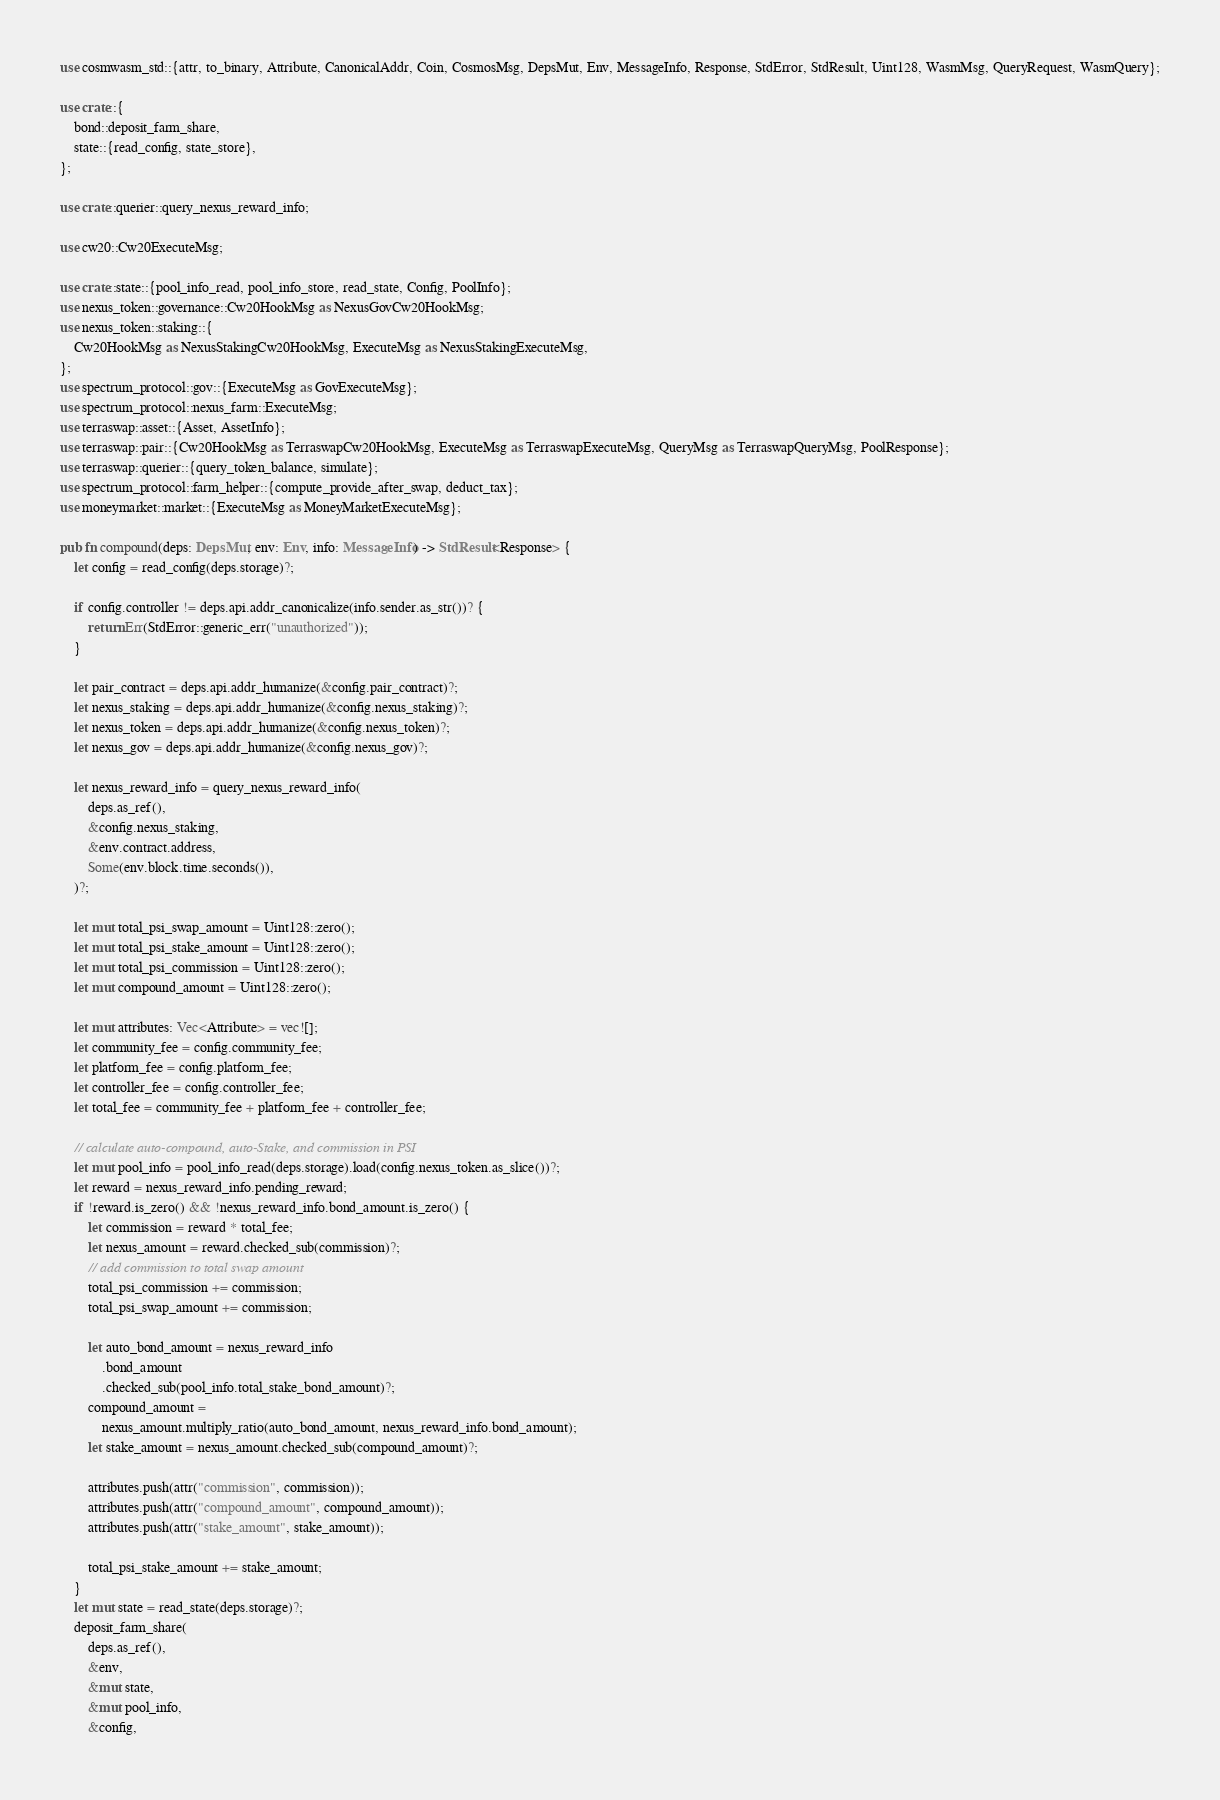Convert code to text. <code><loc_0><loc_0><loc_500><loc_500><_Rust_>use cosmwasm_std::{attr, to_binary, Attribute, CanonicalAddr, Coin, CosmosMsg, DepsMut, Env, MessageInfo, Response, StdError, StdResult, Uint128, WasmMsg, QueryRequest, WasmQuery};

use crate::{
    bond::deposit_farm_share,
    state::{read_config, state_store},
};

use crate::querier::query_nexus_reward_info;

use cw20::Cw20ExecuteMsg;

use crate::state::{pool_info_read, pool_info_store, read_state, Config, PoolInfo};
use nexus_token::governance::Cw20HookMsg as NexusGovCw20HookMsg;
use nexus_token::staking::{
    Cw20HookMsg as NexusStakingCw20HookMsg, ExecuteMsg as NexusStakingExecuteMsg,
};
use spectrum_protocol::gov::{ExecuteMsg as GovExecuteMsg};
use spectrum_protocol::nexus_farm::ExecuteMsg;
use terraswap::asset::{Asset, AssetInfo};
use terraswap::pair::{Cw20HookMsg as TerraswapCw20HookMsg, ExecuteMsg as TerraswapExecuteMsg, QueryMsg as TerraswapQueryMsg, PoolResponse};
use terraswap::querier::{query_token_balance, simulate};
use spectrum_protocol::farm_helper::{compute_provide_after_swap, deduct_tax};
use moneymarket::market::{ExecuteMsg as MoneyMarketExecuteMsg};

pub fn compound(deps: DepsMut, env: Env, info: MessageInfo) -> StdResult<Response> {
    let config = read_config(deps.storage)?;

    if config.controller != deps.api.addr_canonicalize(info.sender.as_str())? {
        return Err(StdError::generic_err("unauthorized"));
    }

    let pair_contract = deps.api.addr_humanize(&config.pair_contract)?;
    let nexus_staking = deps.api.addr_humanize(&config.nexus_staking)?;
    let nexus_token = deps.api.addr_humanize(&config.nexus_token)?;
    let nexus_gov = deps.api.addr_humanize(&config.nexus_gov)?;

    let nexus_reward_info = query_nexus_reward_info(
        deps.as_ref(),
        &config.nexus_staking,
        &env.contract.address,
        Some(env.block.time.seconds()),
    )?;

    let mut total_psi_swap_amount = Uint128::zero();
    let mut total_psi_stake_amount = Uint128::zero();
    let mut total_psi_commission = Uint128::zero();
    let mut compound_amount = Uint128::zero();

    let mut attributes: Vec<Attribute> = vec![];
    let community_fee = config.community_fee;
    let platform_fee = config.platform_fee;
    let controller_fee = config.controller_fee;
    let total_fee = community_fee + platform_fee + controller_fee;

    // calculate auto-compound, auto-Stake, and commission in PSI
    let mut pool_info = pool_info_read(deps.storage).load(config.nexus_token.as_slice())?;
    let reward = nexus_reward_info.pending_reward;
    if !reward.is_zero() && !nexus_reward_info.bond_amount.is_zero() {
        let commission = reward * total_fee;
        let nexus_amount = reward.checked_sub(commission)?;
        // add commission to total swap amount
        total_psi_commission += commission;
        total_psi_swap_amount += commission;

        let auto_bond_amount = nexus_reward_info
            .bond_amount
            .checked_sub(pool_info.total_stake_bond_amount)?;
        compound_amount =
            nexus_amount.multiply_ratio(auto_bond_amount, nexus_reward_info.bond_amount);
        let stake_amount = nexus_amount.checked_sub(compound_amount)?;

        attributes.push(attr("commission", commission));
        attributes.push(attr("compound_amount", compound_amount));
        attributes.push(attr("stake_amount", stake_amount));

        total_psi_stake_amount += stake_amount;
    }
    let mut state = read_state(deps.storage)?;
    deposit_farm_share(
        deps.as_ref(),
        &env,
        &mut state,
        &mut pool_info,
        &config,</code> 